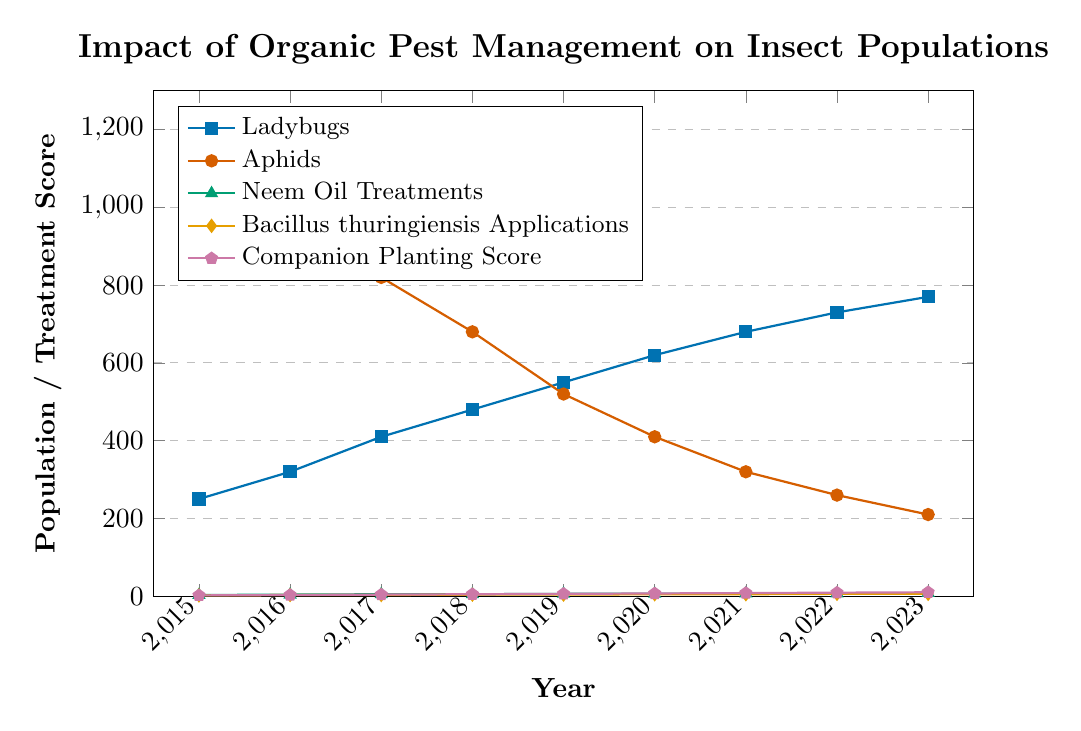What's the overall trend in the population of Ladybugs from 2015 to 2023? To determine the trend, observe the blue line representing Ladybugs. It starts at 250 in 2015 and steadily increases each year, reaching 770 in 2023. This shows a consistent upward trend in Ladybug population over time.
Answer: Upward trend What is the population difference between Ladybugs and Aphids in 2020? In 2020, the Ladybugs' population is 620 (blue line), and the Aphids' population is 410 (red line). The difference is 620 - 410 = 210.
Answer: 210 In which year did Neem Oil Treatments and Bacillus thuringiensis Applications reach the same number of treatments? Identify the points where the green and orange lines intersect. Both lines intersect at 2018, where Neem Oil Treatments and Bacillus thuringiensis Applications were applied equally, each 5 times.
Answer: 2018 By how much did the Companion Planting Score increase from 2015 to 2023? The Companion Planting Score (purple line) in 2015 is 2 and in 2023 is 10. The increase is 10 - 2 = 8.
Answer: 8 Compare the populations of Ladybugs and Aphids in 2018. Which is higher and by how much? In 2018, the Ladybugs' population is 480 (blue line) and the Aphids' population is 680 (red line). The Aphids' population is higher by 680 - 480 = 200.
Answer: Aphids by 200 What is the average number of Neem Oil Treatments applied from 2015 to 2023? The Neem Oil Treatments from 2015 to 2023 are 3, 4, 5, 5, 6, 6, 7, 7, and 8. Sum these values: 3 + 4 + 5 + 5 + 6 + 6 + 7 + 7 + 8 = 51. The average is 51 / 9 = 5.67.
Answer: 5.67 Which year shows the highest decrease in Aphids population year-over-year? To find the highest yearly decrease, consider the differences between consecutive years for Aphids (red line). The decreases are:
2015-2016: 1200 - 980 = 220,
2016-2017: 980 - 820 = 160,
2017-2018: 820 - 680 = 140,
2018-2019: 680 - 520 = 160,
2019-2020: 520 - 410 = 110,
2020-2021: 410 - 320 = 90,
2021-2022: 320 - 260 = 60,
2022-2023: 260 - 210 = 50.
The highest decrease is 220 between 2015 and 2016.
Answer: 2015-2016 